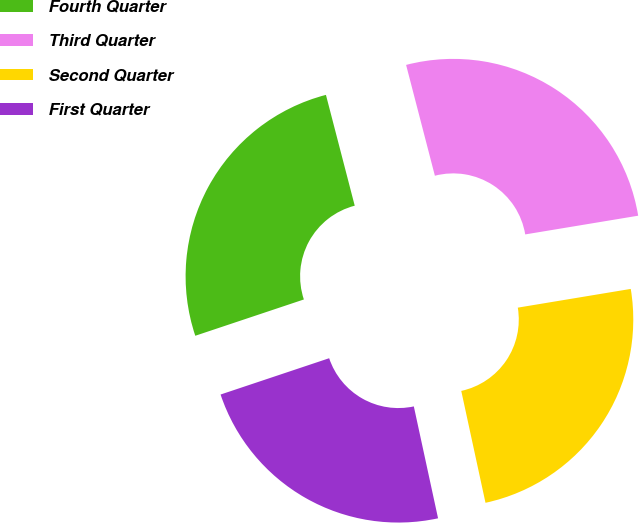Convert chart to OTSL. <chart><loc_0><loc_0><loc_500><loc_500><pie_chart><fcel>Fourth Quarter<fcel>Third Quarter<fcel>Second Quarter<fcel>First Quarter<nl><fcel>26.09%<fcel>26.43%<fcel>24.22%<fcel>23.26%<nl></chart> 